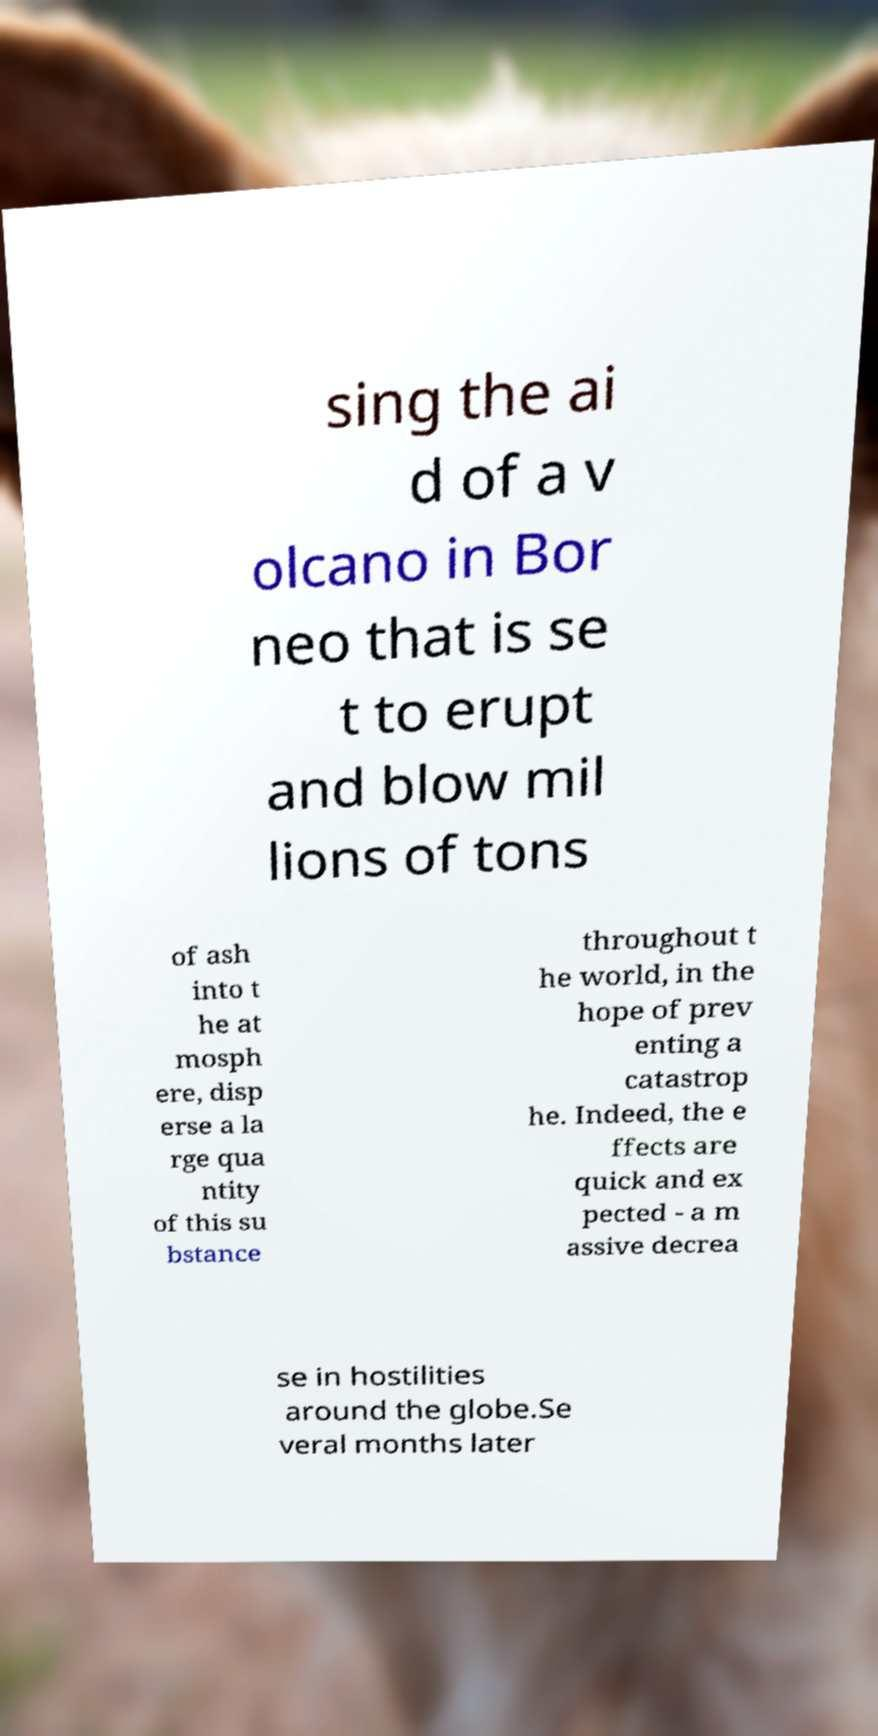There's text embedded in this image that I need extracted. Can you transcribe it verbatim? sing the ai d of a v olcano in Bor neo that is se t to erupt and blow mil lions of tons of ash into t he at mosph ere, disp erse a la rge qua ntity of this su bstance throughout t he world, in the hope of prev enting a catastrop he. Indeed, the e ffects are quick and ex pected - a m assive decrea se in hostilities around the globe.Se veral months later 